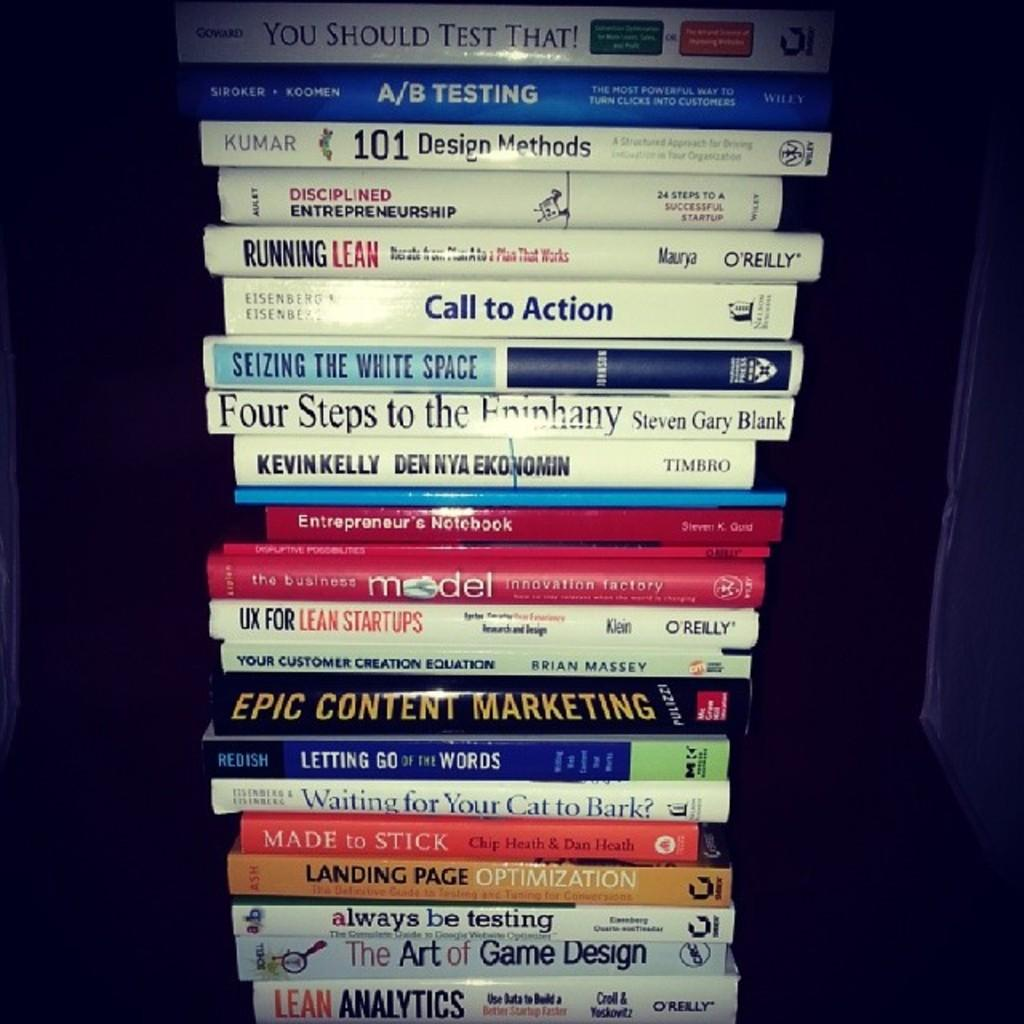<image>
Give a short and clear explanation of the subsequent image. A stack of books piled high, including Epic Content Marketing and Call to Action. 